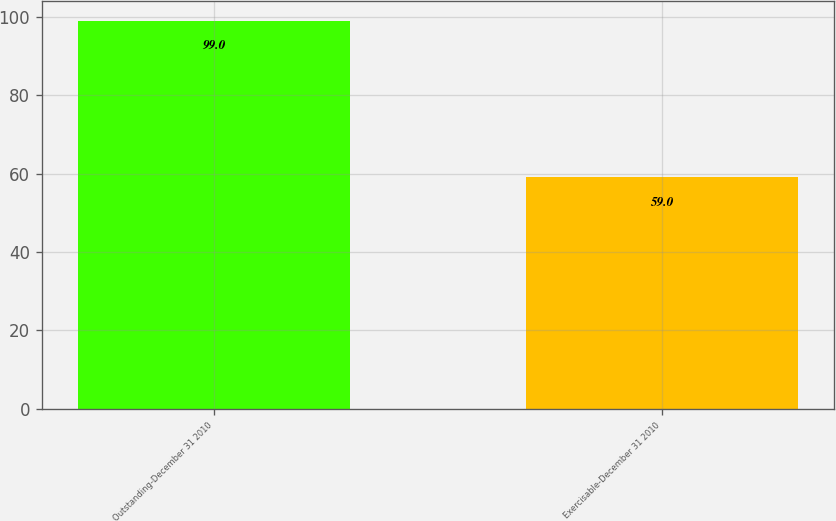Convert chart. <chart><loc_0><loc_0><loc_500><loc_500><bar_chart><fcel>Outstanding-December 31 2010<fcel>Exercisable-December 31 2010<nl><fcel>99<fcel>59<nl></chart> 